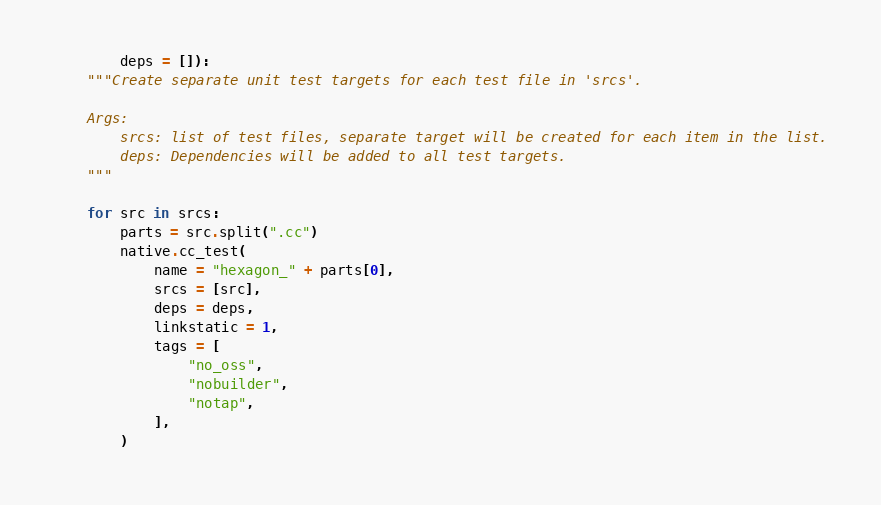<code> <loc_0><loc_0><loc_500><loc_500><_Python_>        deps = []):
    """Create separate unit test targets for each test file in 'srcs'.

    Args:
        srcs: list of test files, separate target will be created for each item in the list.
        deps: Dependencies will be added to all test targets.
    """

    for src in srcs:
        parts = src.split(".cc")
        native.cc_test(
            name = "hexagon_" + parts[0],
            srcs = [src],
            deps = deps,
            linkstatic = 1,
            tags = [
                "no_oss",
                "nobuilder",
                "notap",
            ],
        )
</code> 